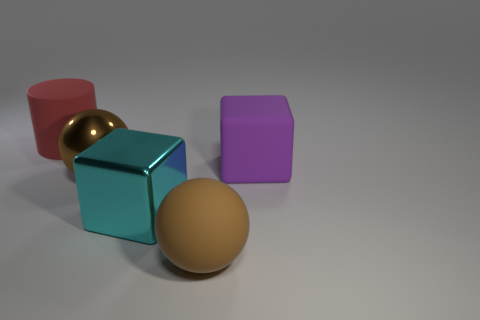What is the size of the matte thing that is in front of the cube that is behind the metal block?
Your answer should be compact. Large. What is the large cube on the right side of the brown rubber ball made of?
Make the answer very short. Rubber. How many things are large objects in front of the big red matte cylinder or objects that are to the right of the shiny sphere?
Keep it short and to the point. 4. What material is the other large thing that is the same shape as the large cyan metallic thing?
Offer a terse response. Rubber. There is a object that is in front of the cyan metal thing; is it the same color as the large sphere behind the cyan metallic block?
Keep it short and to the point. Yes. Is there a purple matte sphere of the same size as the shiny sphere?
Your response must be concise. No. What is the large object that is behind the brown shiny object and in front of the big cylinder made of?
Give a very brief answer. Rubber. How many matte things are big blocks or big purple things?
Provide a short and direct response. 1. There is a brown object that is the same material as the cyan block; what shape is it?
Ensure brevity in your answer.  Sphere. What number of large matte objects are behind the big brown shiny thing and to the left of the large purple rubber object?
Provide a succinct answer. 1. 